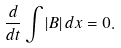Convert formula to latex. <formula><loc_0><loc_0><loc_500><loc_500>\frac { d } { d t } \int | B | \, d x = 0 .</formula> 